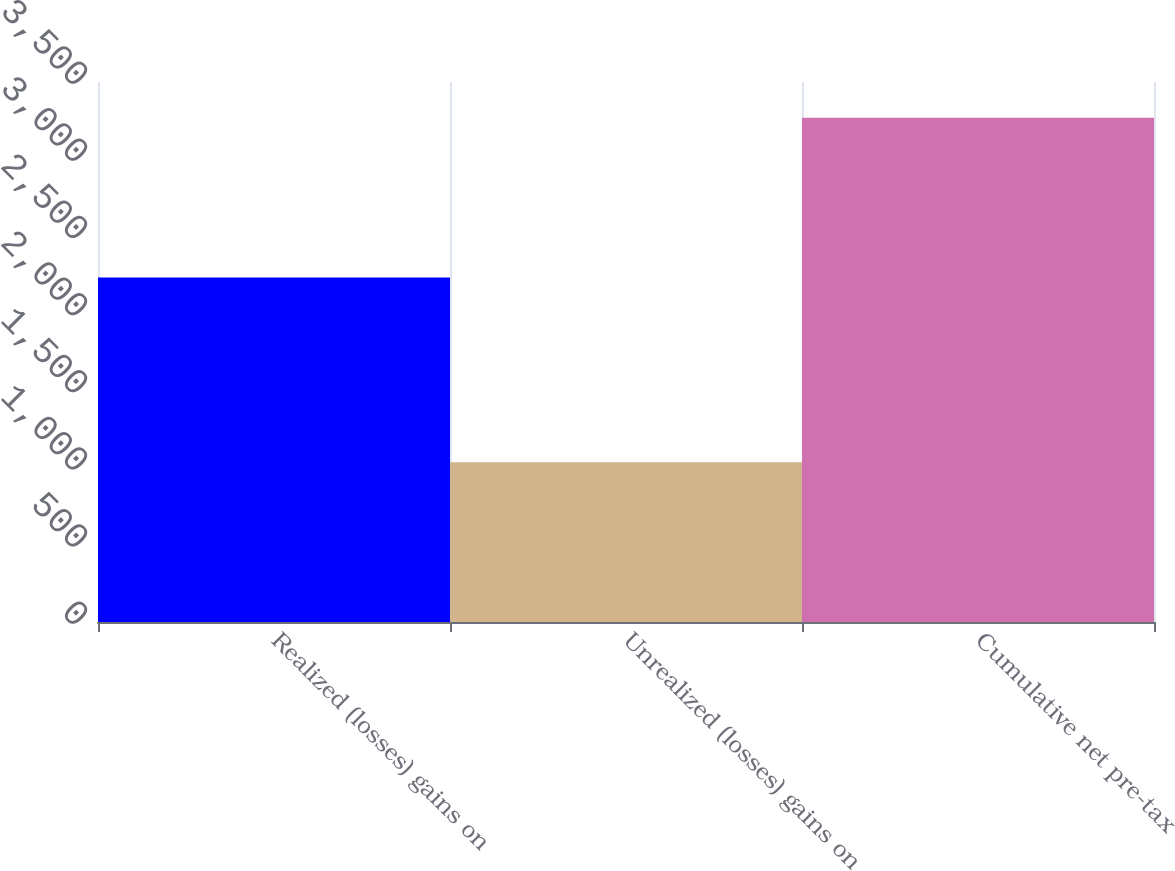<chart> <loc_0><loc_0><loc_500><loc_500><bar_chart><fcel>Realized (losses) gains on<fcel>Unrealized (losses) gains on<fcel>Cumulative net pre-tax<nl><fcel>2233<fcel>1035<fcel>3268<nl></chart> 